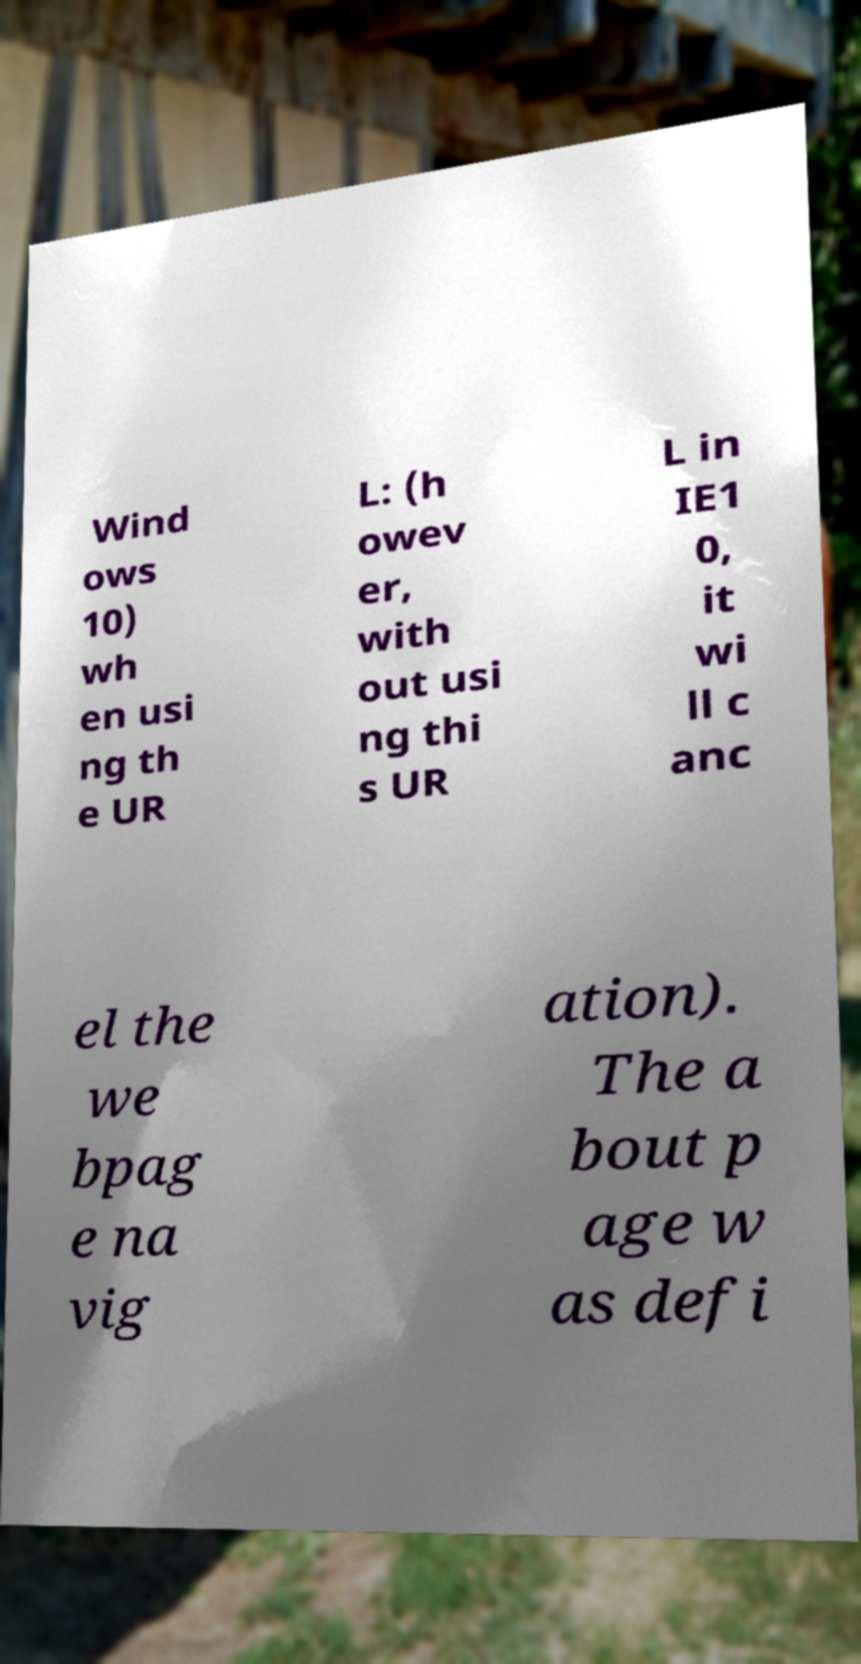What messages or text are displayed in this image? I need them in a readable, typed format. Wind ows 10) wh en usi ng th e UR L: (h owev er, with out usi ng thi s UR L in IE1 0, it wi ll c anc el the we bpag e na vig ation). The a bout p age w as defi 